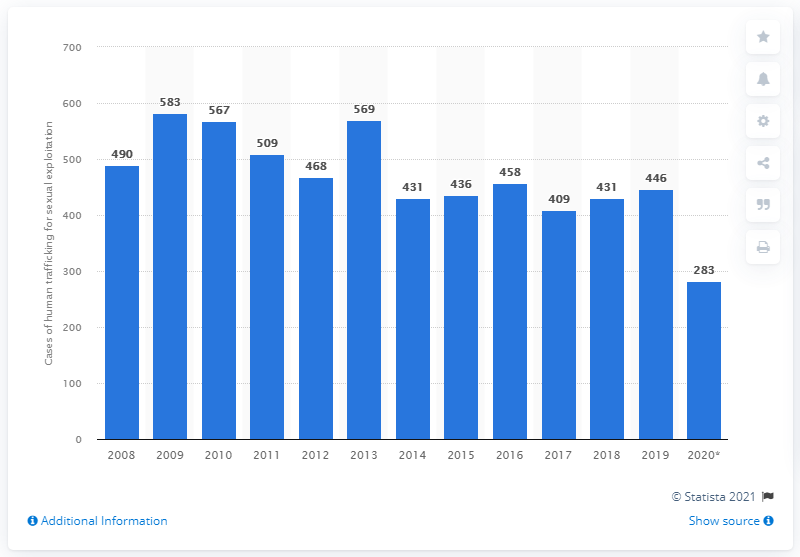Can you explain the trend in human trafficking cases for sexual exploitation over the years according to this chart? Certainly. The bar chart presents a time series of the number of human trafficking cases for sexual exploitation from 2008 to 2020. We can observe a general fluctuating decline over the years. After peaking in 2009 and 2011, there's a noteworthly downtrend, reaching the lowest point in 2020 with 283 cases. It's important to examine broader factors, like changes in awareness, reporting mechanisms, law enforcement efforts, and social conditions, to fully understand why these numbers have changed over time. 